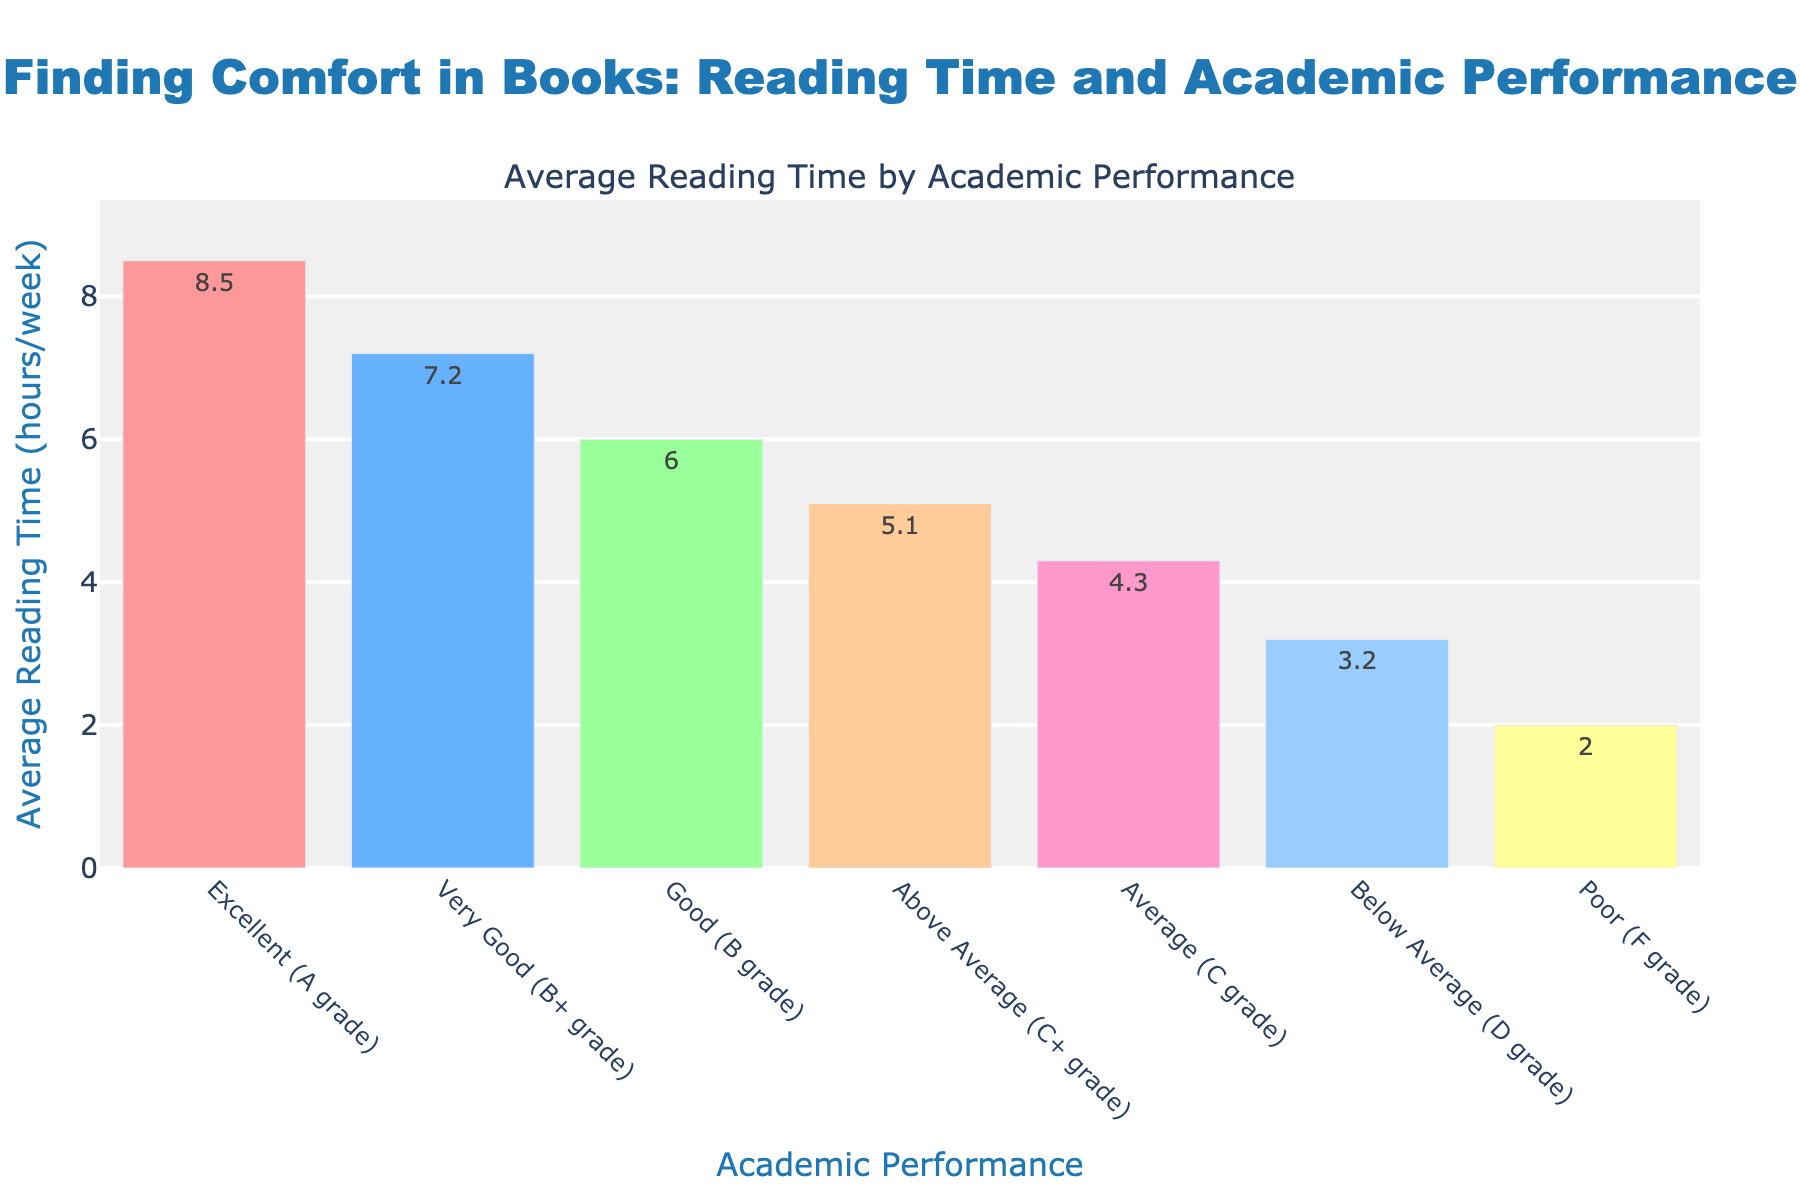What is the average reading time for students with Excellent (A grade) performance? The bar corresponding to Excellent (A grade) academic performance shows an average reading time of 8.5 hours per week.
Answer: 8.5 hours Which academic performance category has the lowest average reading time? The bar corresponding to Poor (F grade) academic performance shows the lowest reading time of 2.0 hours per week.
Answer: Poor (F grade) How much more do students with Very Good (B+ grade) read compared to students with Average (C grade)? The average reading time for Very Good (B+ grade) is 7.2 hours per week, and for Average (C grade) it is 4.3 hours per week. The difference is 7.2 - 4.3 = 2.9 hours per week.
Answer: 2.9 hours What's the total average reading time for students with Above Average (C+ grade), Good (B grade), and Very Good (B+ grade) performance? The average reading times for Above Average (C+ grade), Good (B grade), and Very Good (B+ grade) is 5.1, 6.0, and 7.2 hours per week respectively. Adding these values gives 5.1 + 6.0 + 7.2 = 18.3 hours per week.
Answer: 18.3 hours Do students with Above Average (C+ grade) read more or less than students with Below Average (D grade)? The average reading time for Above Average (C+ grade) is 5.1 hours per week, while for Below Average (D grade), it is 3.2 hours per week. Thus, Above Average (C+ grade) students read more.
Answer: More What is the visual difference in bar length between Excellent (A grade) and Poor (F grade) performance? The bar for Excellent (A grade) is the tallest, representing 8.5 hours per week, while the bar for Poor (F grade) is the shortest, representing 2.0 hours per week. The visual difference in their heights corresponds to the difference in average reading time, which is 8.5 - 2.0 = 6.5 hours.
Answer: 6.5 hours Rank the academic performance categories from highest to lowest based on average reading time. The bars indicate the following ranking based on the height: Excellent (A grade), Very Good (B+ grade), Good (B grade), Above Average (C+ grade), Average (C grade), Below Average (D grade), Poor (F grade).
Answer: Excellent (A grade), Very Good (B+ grade), Good (B grade), Above Average (C+ grade), Average (C grade), Below Average (D grade), Poor (F grade) What is the difference in average reading time between students with Excellent (A grade) and Average (C grade) performance? The average reading time for Excellent (A grade) is 8.5 hours per week, while for Average (C grade) it is 4.3 hours per week. The difference is 8.5 - 4.3 = 4.2 hours.
Answer: 4.2 hours Which academic performance category shows approximately twice as much reading time as Below Average (D grade)? The average reading time for Below Average (D grade) is 3.2 hours per week. Approximately twice this is 3.2 * 2 = 6.4 hours per week. The Good (B grade) category, with an average reading time of 6.0 hours, is close to this value.
Answer: Good (B grade) Is there a notable trend between academic performance and average reading time? Observing the bars, we see that as academic performance improves from Poor (F grade) to Excellent (A grade), the average reading time increases steadily. This suggests a positive trend where higher academic performance is associated with more reading time.
Answer: Positive trend 